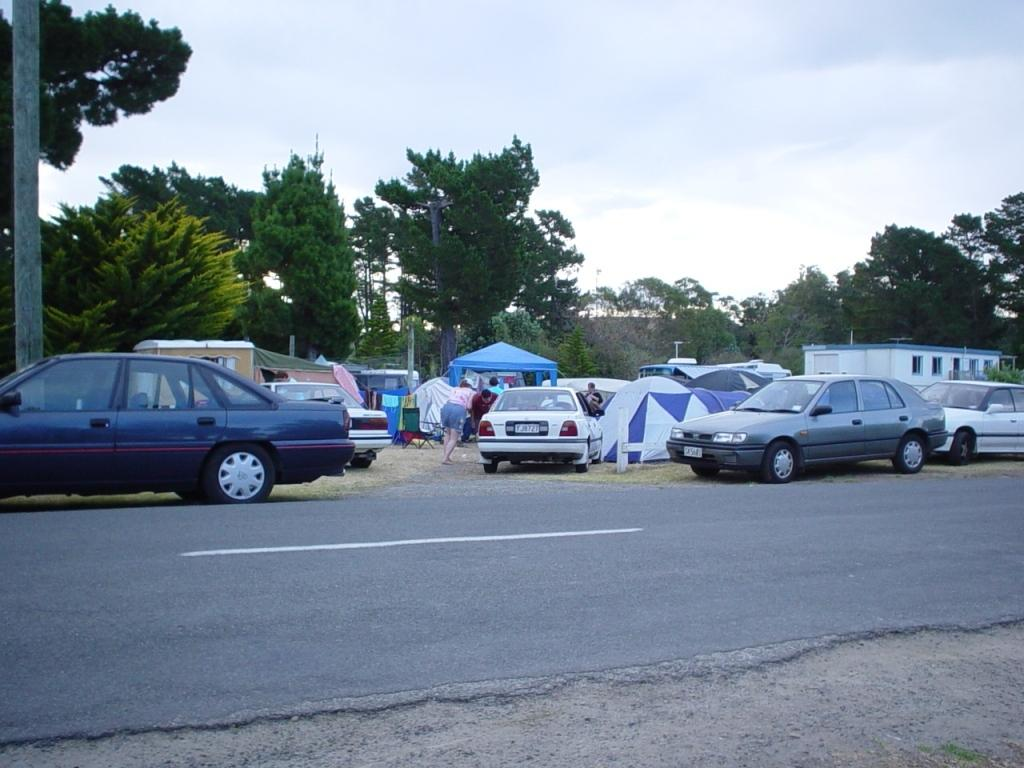What can be seen on the road in the image? There are vehicles on the road in the image. What is visible in the background of the image? There are tents, trees, poles, and a building in the background of the image. What is visible at the top of the image? The sky is visible at the top of the image. What type of pen is being used to write on the tents in the image? There is no pen or writing visible on the tents in the image. What is the interest rate of the loan being discussed in the image? There is no discussion of loans or interest rates in the image. 